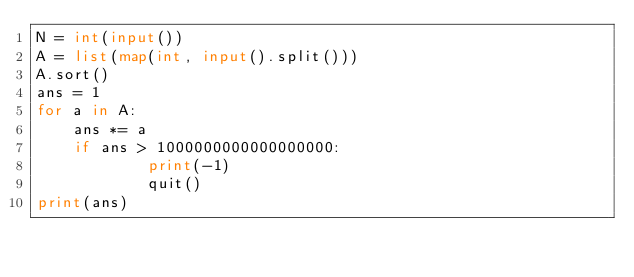Convert code to text. <code><loc_0><loc_0><loc_500><loc_500><_Python_>N = int(input())
A = list(map(int, input().split()))
A.sort()
ans = 1
for a in A:
    ans *= a
    if ans > 1000000000000000000:
            print(-1)
            quit()
print(ans)</code> 